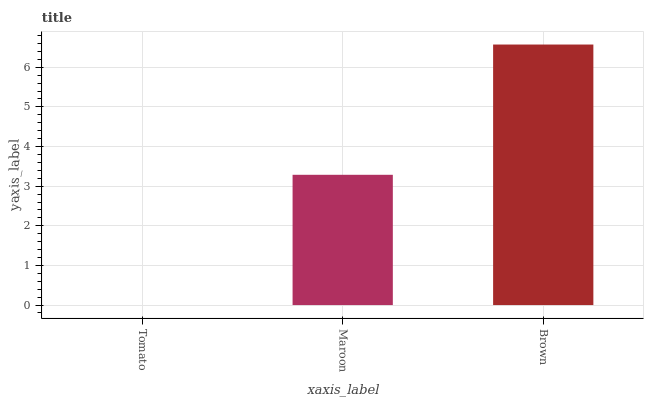Is Maroon the minimum?
Answer yes or no. No. Is Maroon the maximum?
Answer yes or no. No. Is Maroon greater than Tomato?
Answer yes or no. Yes. Is Tomato less than Maroon?
Answer yes or no. Yes. Is Tomato greater than Maroon?
Answer yes or no. No. Is Maroon less than Tomato?
Answer yes or no. No. Is Maroon the high median?
Answer yes or no. Yes. Is Maroon the low median?
Answer yes or no. Yes. Is Tomato the high median?
Answer yes or no. No. Is Tomato the low median?
Answer yes or no. No. 